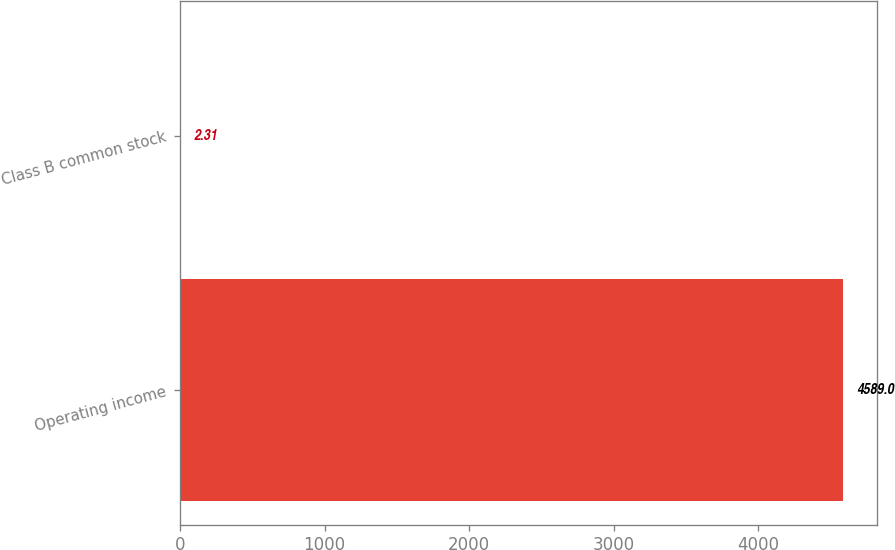Convert chart. <chart><loc_0><loc_0><loc_500><loc_500><bar_chart><fcel>Operating income<fcel>Class B common stock<nl><fcel>4589<fcel>2.31<nl></chart> 